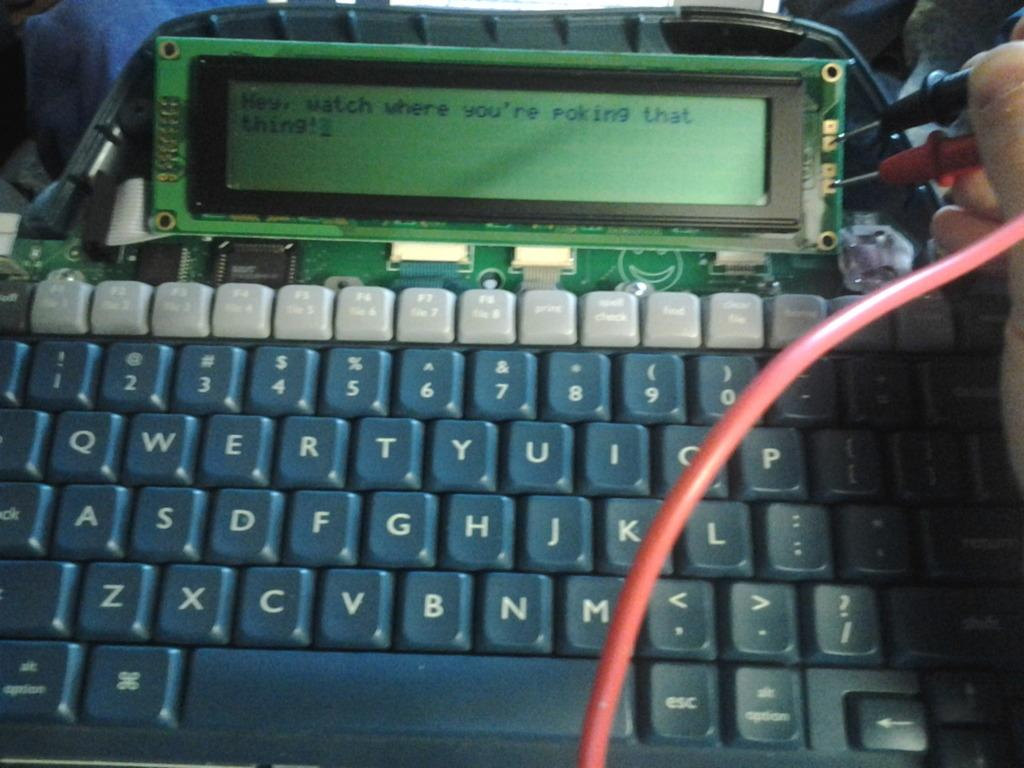<image>
Relay a brief, clear account of the picture shown. Computer keyboard with a screen that says "Watch where you're poking that thing!". 